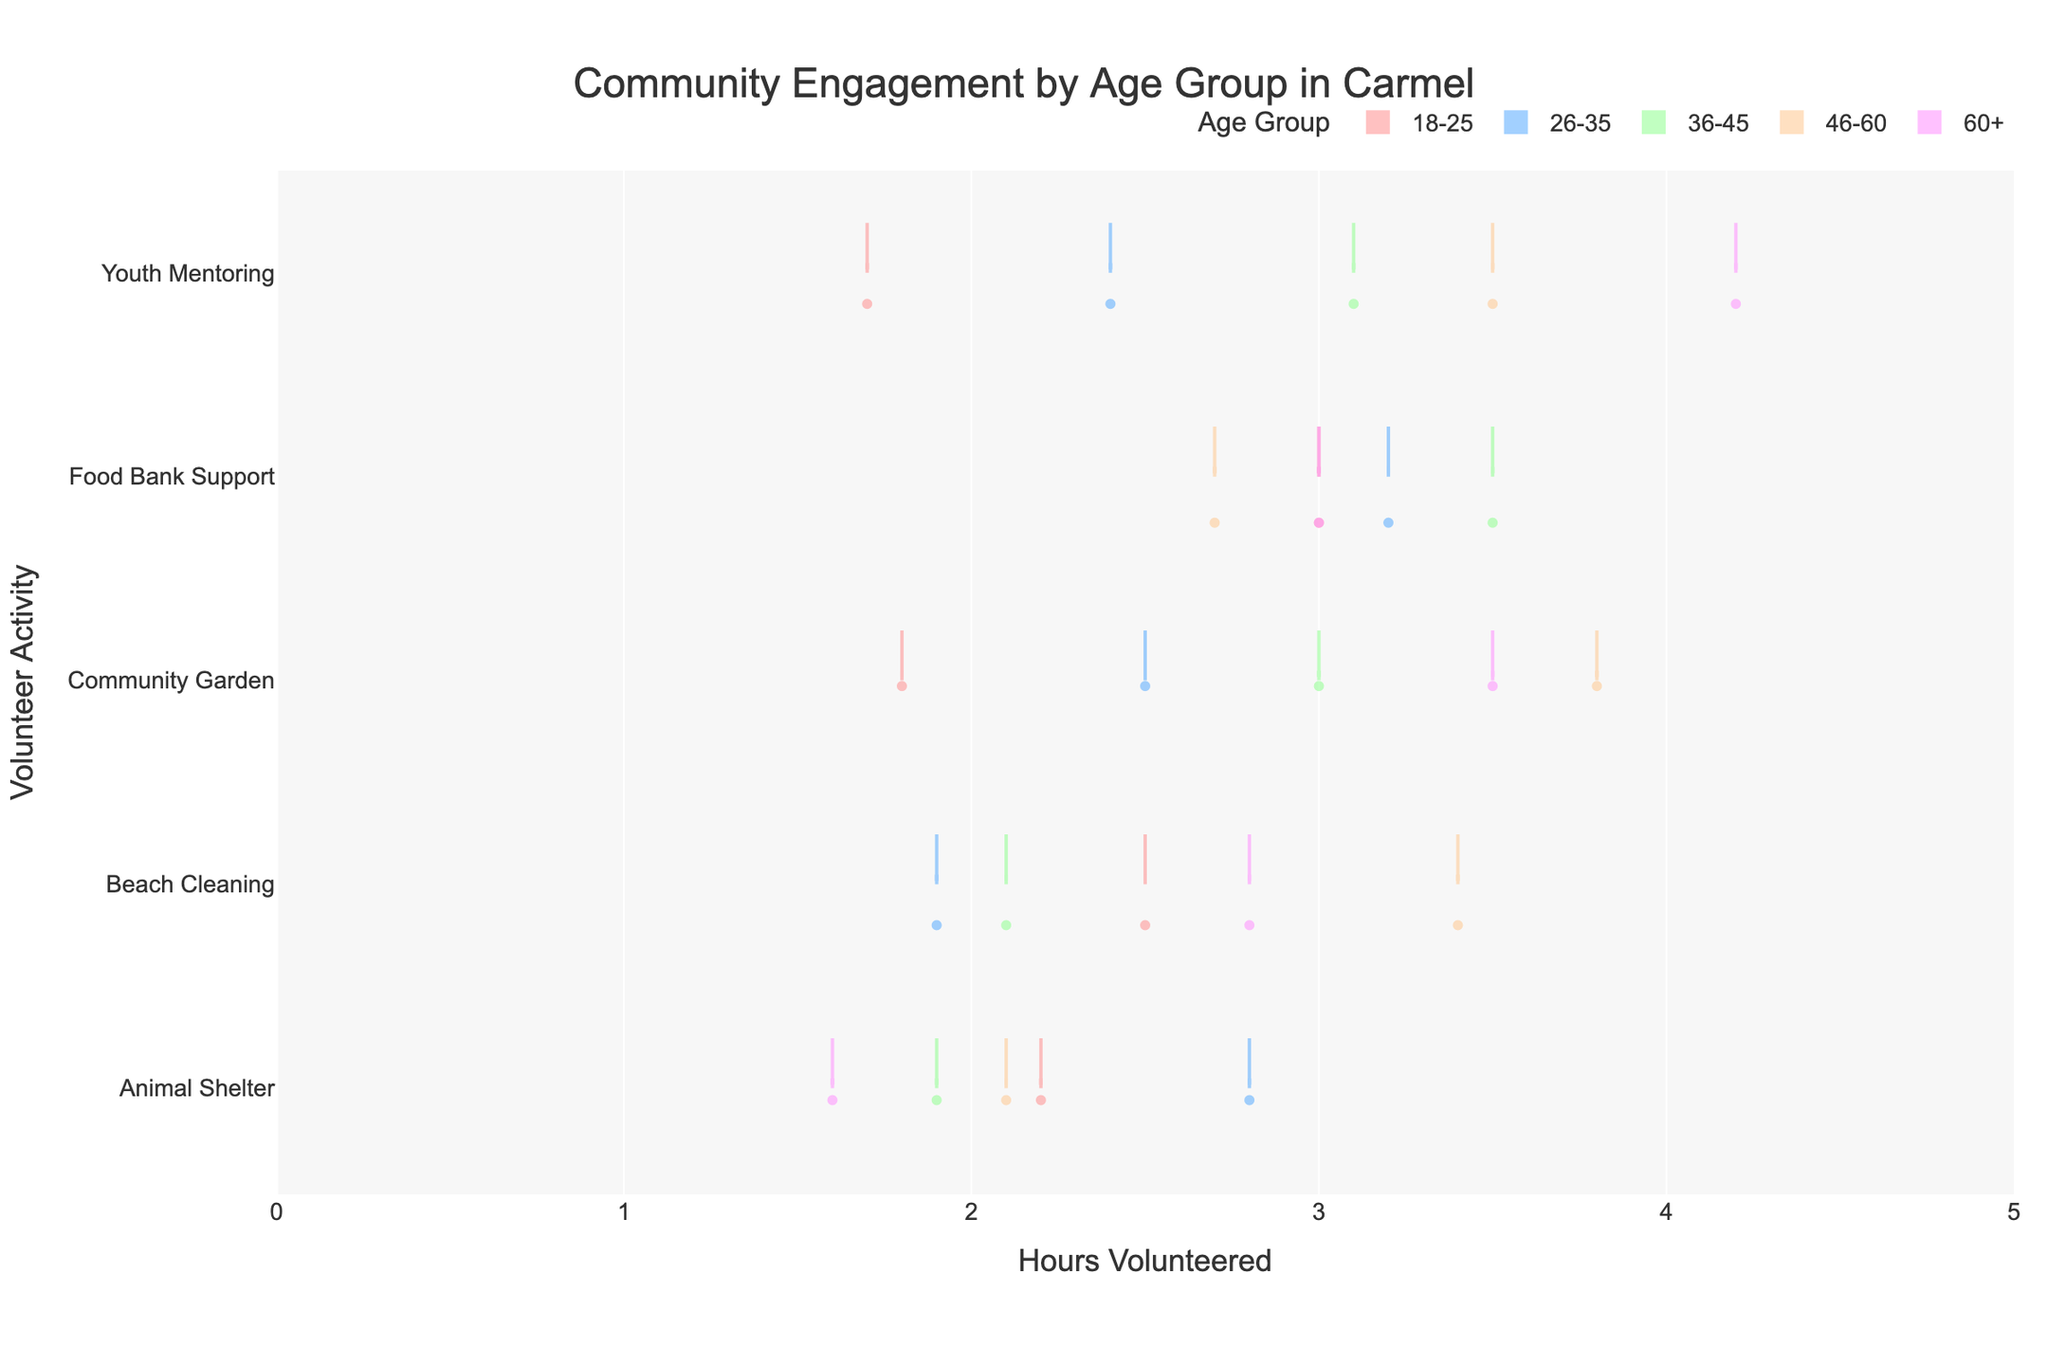What's the range of hours volunteered for Beach Cleaning by the 18-25 age group? To find the range, identify the minimum and maximum hours volunteered for Beach Cleaning by the 18-25 age group. In the chart, these are represented by the points within that age group's violin for Beach Cleaning.
Answer: 1.7 to 3.0 Which age group has the widest spread of volunteered hours for Youth Mentoring? A wider spread in the violin plot indicates more variability in the volunteered hours. Look for the age group with the broadest violin for Youth Mentoring.
Answer: 60+ How do the average hours volunteered for Community Garden compare between the 26-35 and 46-60 age groups? Compare the mean lines (often solid or dashed) within the violins for the 26-35 and 46-60 age groups under Community Garden.
Answer: 46-60 volunteers more on average Which volunteer activity has the highest median hours volunteered among all age groups? Identify the median lines (center of the violins) for each activity and determine which one aligns highest on the x-axis.
Answer: Youth Mentoring How many different volunteer activities show a mean line in the 2-3 hour range for the 36-45 age group? For the 36-45 age group, count the number of violins whose mean lines fall between 2 and 3 on the x-axis.
Answer: 2 What is the most popular volunteer activity for the 46-60 age group in terms of hours volunteered? Look for the violin with the most substantial area under the curve (or the highest mean line) for the 46-60 age group.
Answer: Community Garden Comparing the 18-25 and 60+ age groups, which has a higher average for Animal Shelter volunteering? Check the mean lines for the 18-25 and 60+ age groups’ violins under Animal Shelter and compare their positions on the x-axis.
Answer: 18-25 Which age group shows the least variability in hours volunteered for Food Bank Support? The least variability will have the narrowest violin or closest range between quartiles for Food Bank Support.
Answer: 18-25 